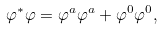Convert formula to latex. <formula><loc_0><loc_0><loc_500><loc_500>\varphi ^ { \ast } \varphi = \varphi ^ { a } \varphi ^ { a } + \varphi ^ { 0 } \varphi ^ { 0 } ,</formula> 